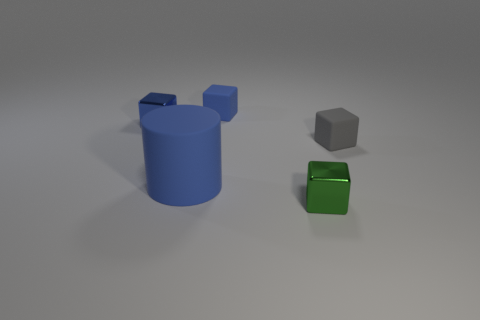Add 1 blue cylinders. How many objects exist? 6 Subtract all blocks. How many objects are left? 1 Add 4 tiny gray matte things. How many tiny gray matte things exist? 5 Subtract 0 green cylinders. How many objects are left? 5 Subtract all large blue spheres. Subtract all rubber cubes. How many objects are left? 3 Add 5 green blocks. How many green blocks are left? 6 